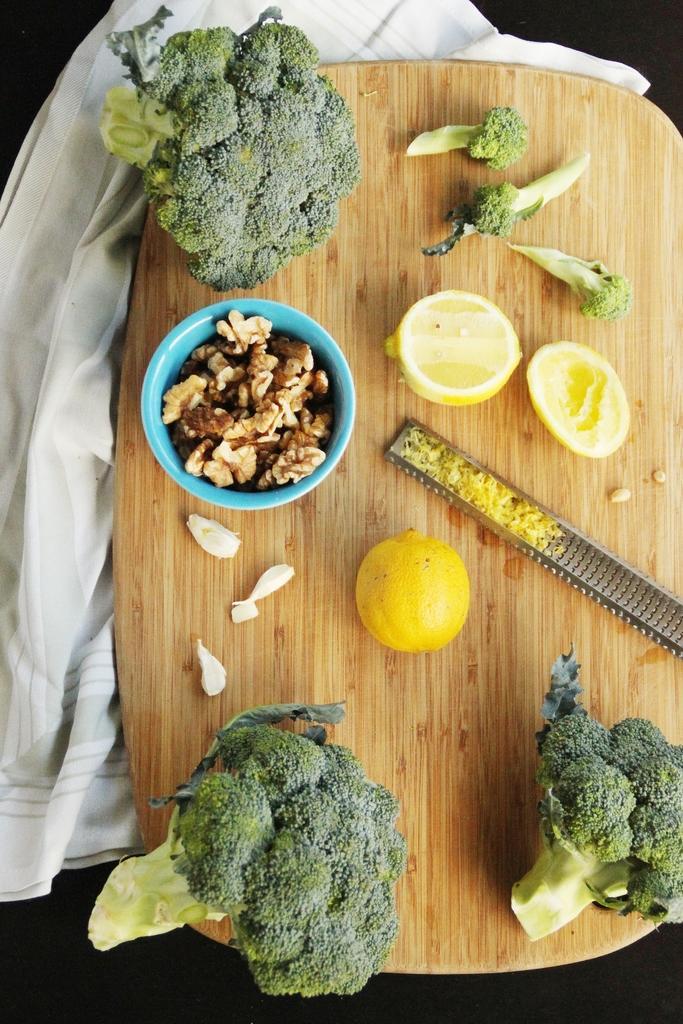Describe this image in one or two sentences. In this image we can see broccoli and lemons placed on the table. Under the table there is a cloth. 